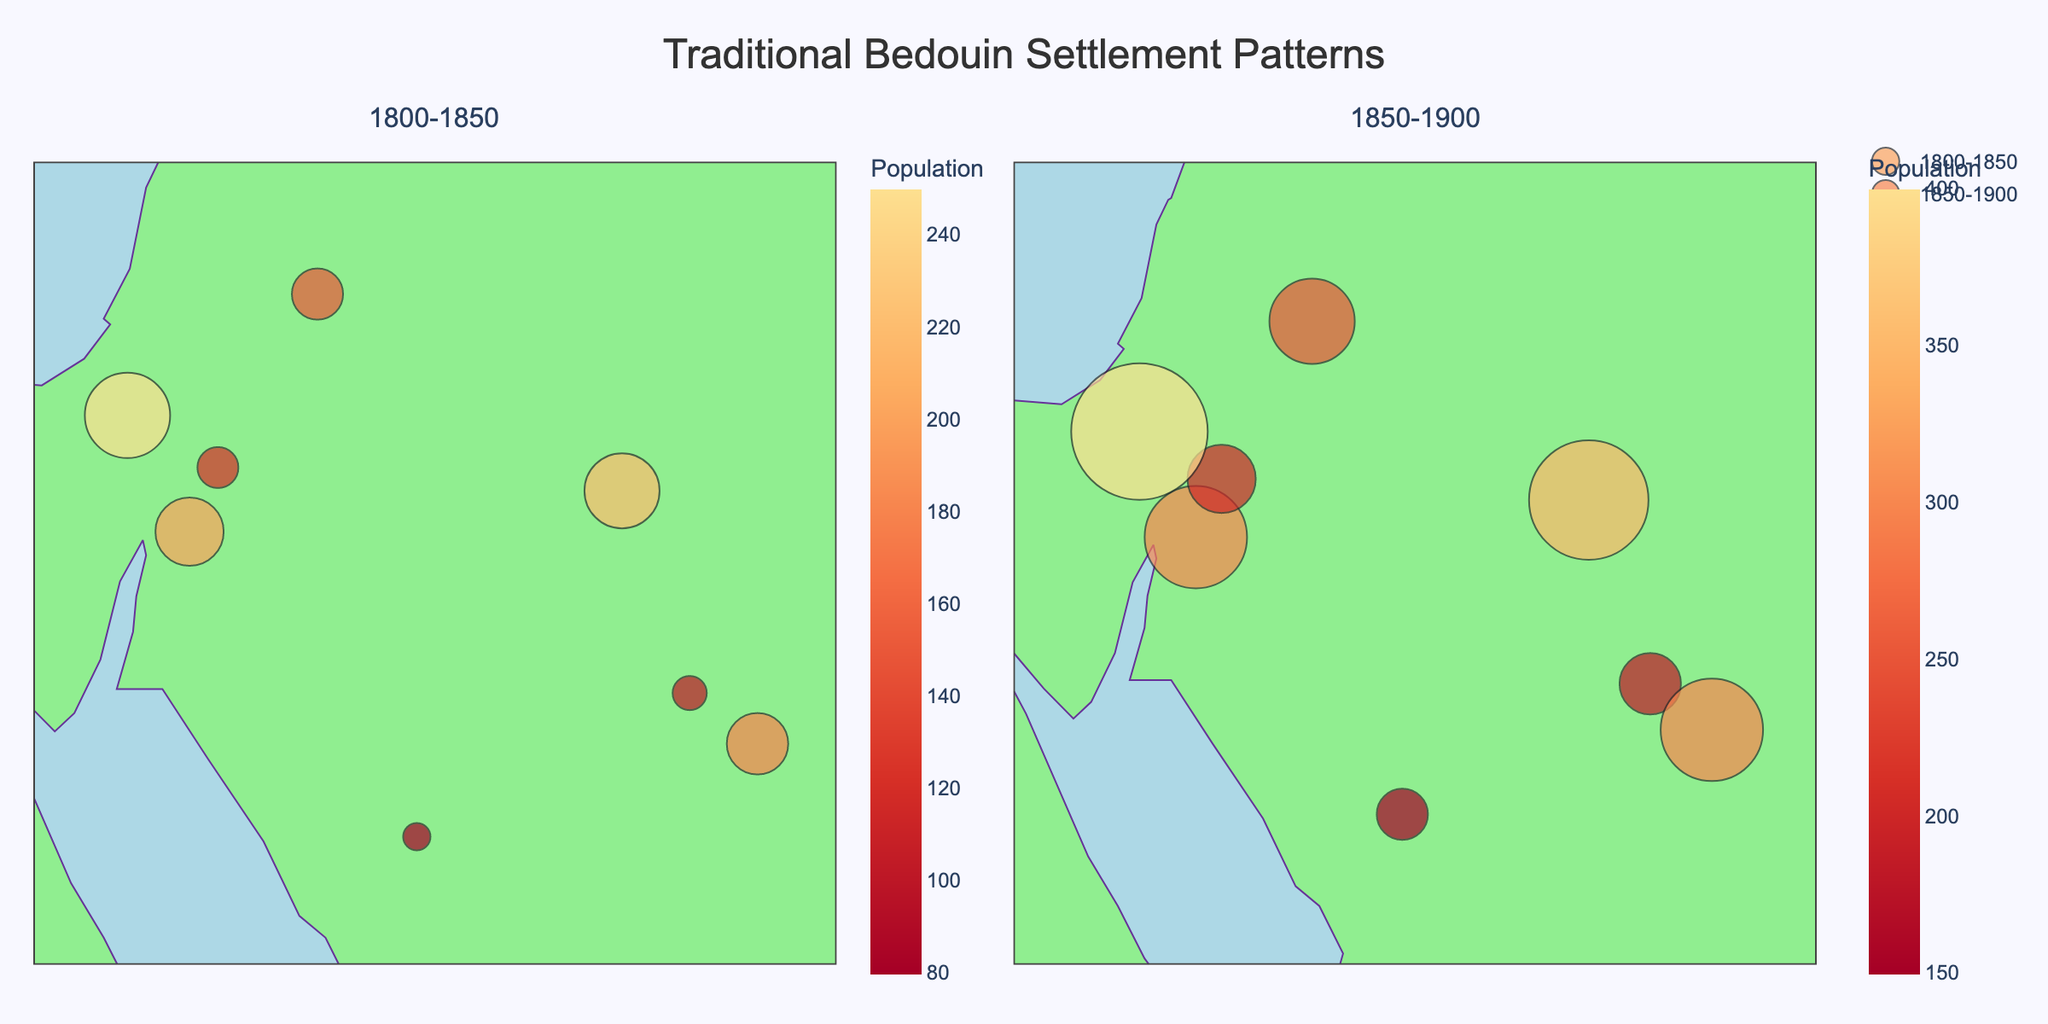What's the title of the figure? The title is usually prominently displayed and aims to convey the main topic of the figure. In this case, it clearly states "Traditional Bedouin Settlement Patterns."
Answer: Traditional Bedouin Settlement Patterns How is the population distribution different between the two time periods? By comparing the sizes and colors of the markers in both subplots, it appears that settlements have larger populations in the second time period (1850-1900) compared to the first (1800-1850), indicating population growth.
Answer: Larger in 1850-1900 Which settlement has the highest population in the 1850-1900 period? Looking at the second subplot, the largest marker and the darkest color (indicating highest population) is in the "Negev Desert" with a population of 400.
Answer: Negev Desert What is the population change in Wadi Rum from the 1800-1850 period to the 1850-1900 period? The population in Wadi Rum changes from 200 in the 1800-1850 period to 300 in the 1850-1900 period. Subtracting these values gives a change of 100.
Answer: 100 increase Which period has more settlements with a population greater than 200? By examining both subplots, the 1850-1900 period has more markers larger than 200 (Negev Desert, Al Jowf, Hail, Wadi Rum) compared to the 1800-1850 period.
Answer: 1850-1900 Identify a settlement with consistent population growth across both periods? Several settlements show consistent population growth, but one example is "Ma'an" which grows from 120 to 200 in the time periods.
Answer: Ma'an Which period shows a higher concentration of populated settlements in southern geographical coordinates? In the first subplot (1800-1850), fewer large markers are located in the south compared to the second subplot (1850-1900), where southern settlements like Wadi Rum and Ma'an show significant populations.
Answer: 1850-1900 Compare the latitude and longitude range of settlements between the two periods. Which has a broader range? By visually inspecting the distribution of markers in both subplots, the 1800-1850 period has a slightly narrower range in both latitude and longitude compared to 1850-1900.
Answer: 1850-1900 